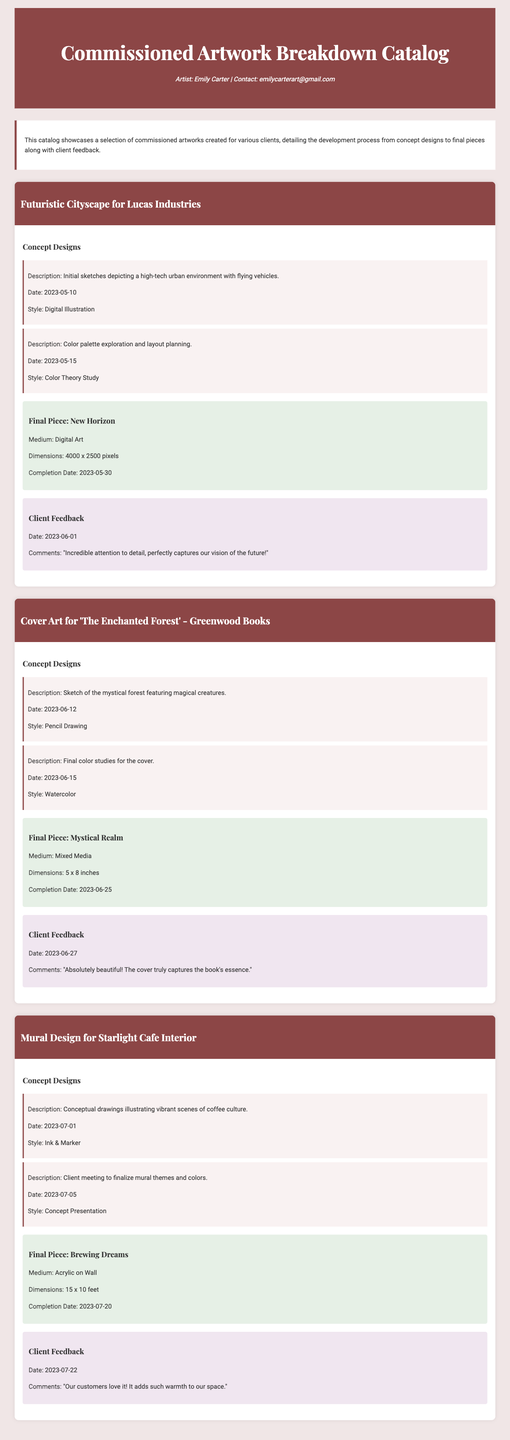what is the name of the artist? The document includes a section that introduces the artist as Emily Carter.
Answer: Emily Carter what is the completion date of the final piece for Lucas Industries? The document provides the completion date for the final piece "New Horizon" under the Lucas Industries project as 2023-05-30.
Answer: 2023-05-30 what medium was used for the final piece 'Mystical Realm'? The document states that the final piece for the cover art was created using Mixed Media.
Answer: Mixed Media how many concept designs were created for the Starlight Cafe mural? The document mentions two concept designs in the project section for the Starlight Cafe mural.
Answer: Two what was the client feedback date for 'The Enchanted Forest'? The document lists the client feedback date for 'The Enchanted Forest' as 2023-06-27.
Answer: 2023-06-27 what dimension is the final piece 'Brewing Dreams'? The final piece 'Brewing Dreams' is detailed with dimensions of 15 x 10 feet in the document.
Answer: 15 x 10 feet what style was the color palette exploration for Lucas Industries? The document specifies that the style for the color palette exploration was a Color Theory Study.
Answer: Color Theory Study what is the title of the final piece for Lucas Industries? The title of the final piece created for Lucas Industries is "New Horizon".
Answer: New Horizon who is the client for the project featuring 'Mystical Realm'? The document indicates that the client for the project featuring 'Mystical Realm' is Greenwood Books.
Answer: Greenwood Books 